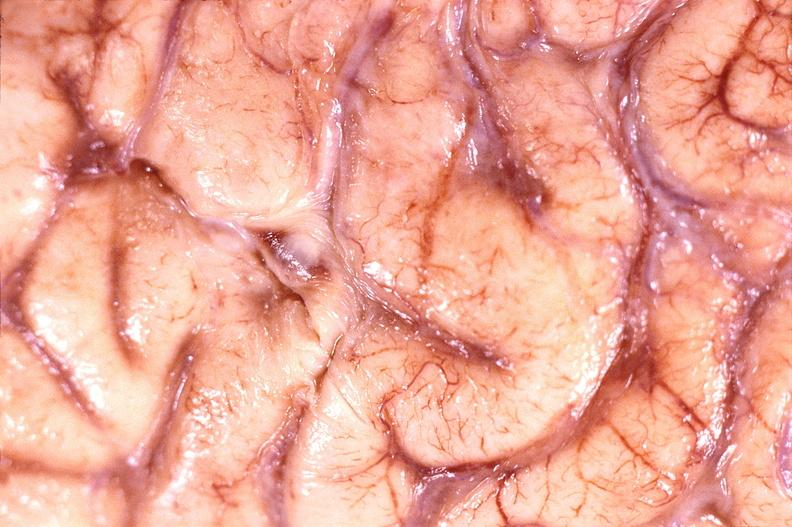does metastatic neuroblastoma show brain abscess?
Answer the question using a single word or phrase. No 